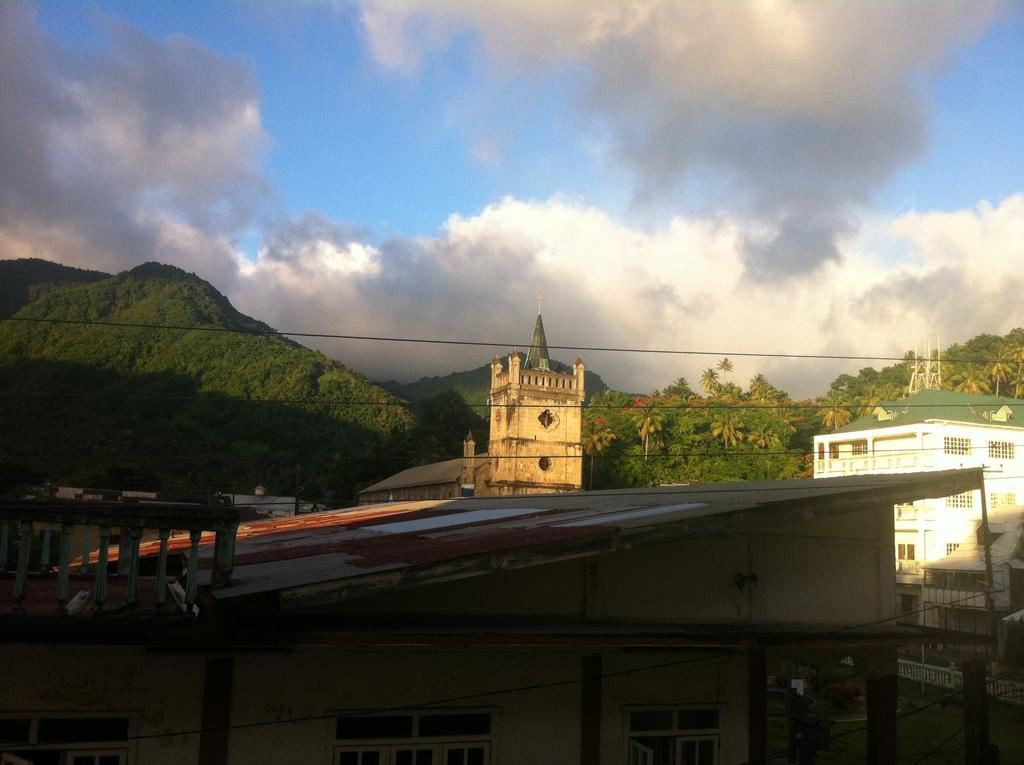What type of structures can be seen in the image? There are buildings in the image. What is located behind the buildings? There are many trees behind the buildings. What geographical feature is visible in the image? There is a hill visible in the image. What covers the hill in the image? The hill is covered with plants and trees. Can you see any furniture on the hill in the image? There is no furniture visible on the hill in the image. What type of mark can be seen on the buildings in the image? There is no mark mentioned on the buildings in the image. 